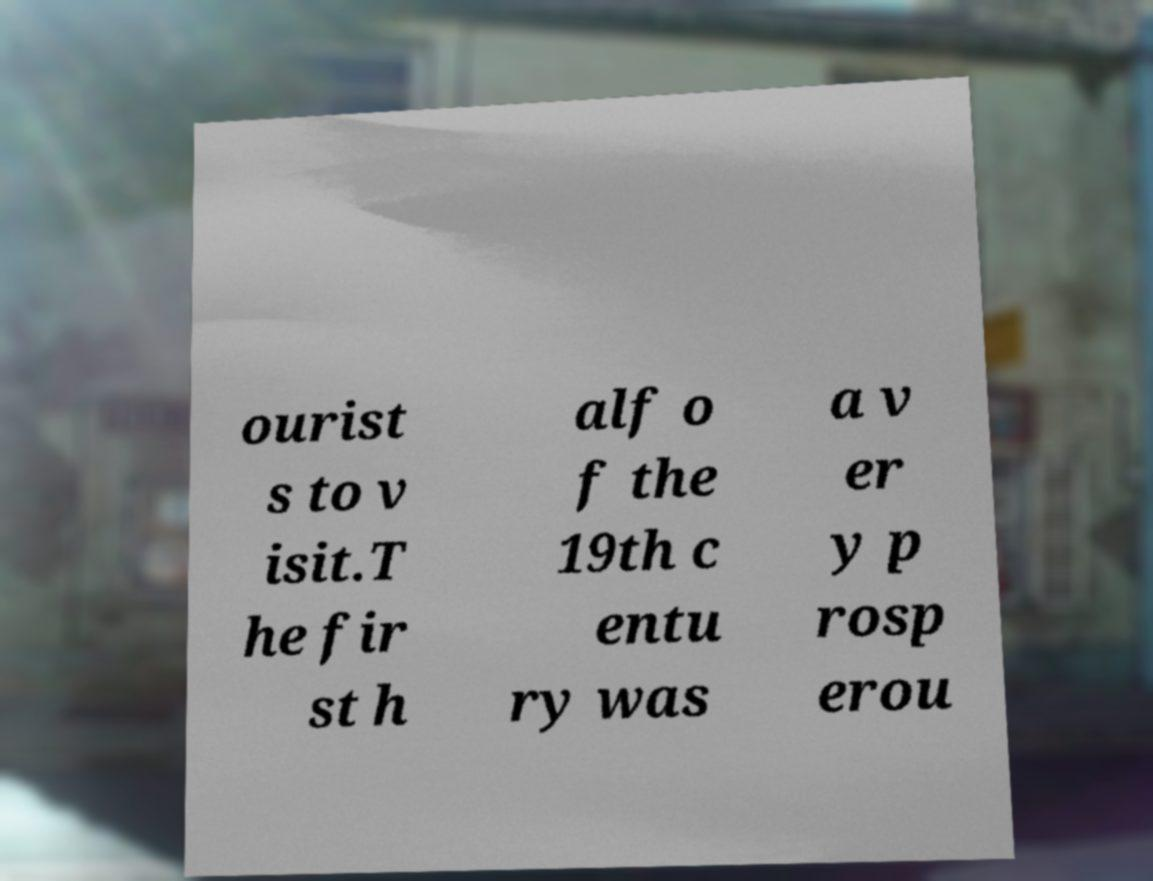Could you extract and type out the text from this image? ourist s to v isit.T he fir st h alf o f the 19th c entu ry was a v er y p rosp erou 